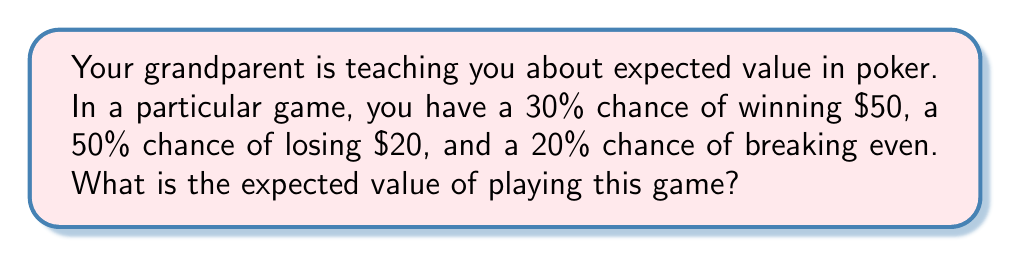Help me with this question. Let's approach this step-by-step:

1) The expected value (EV) is calculated by multiplying each possible outcome by its probability and then summing these products.

2) We have three possible outcomes:
   a) Winning $50 with 30% probability
   b) Losing $20 with 50% probability
   c) Breaking even ($0) with 20% probability

3) Let's calculate the EV for each outcome:
   a) $EV(\text{win}) = 50 \times 0.30 = 15$
   b) $EV(\text{lose}) = -20 \times 0.50 = -10$
   c) $EV(\text{break even}) = 0 \times 0.20 = 0$

4) Now, we sum these values:
   $$EV(\text{total}) = EV(\text{win}) + EV(\text{lose}) + EV(\text{break even})$$
   $$EV(\text{total}) = 15 + (-10) + 0 = 5$$

5) Therefore, the expected value of playing this game is $5.
Answer: $5 